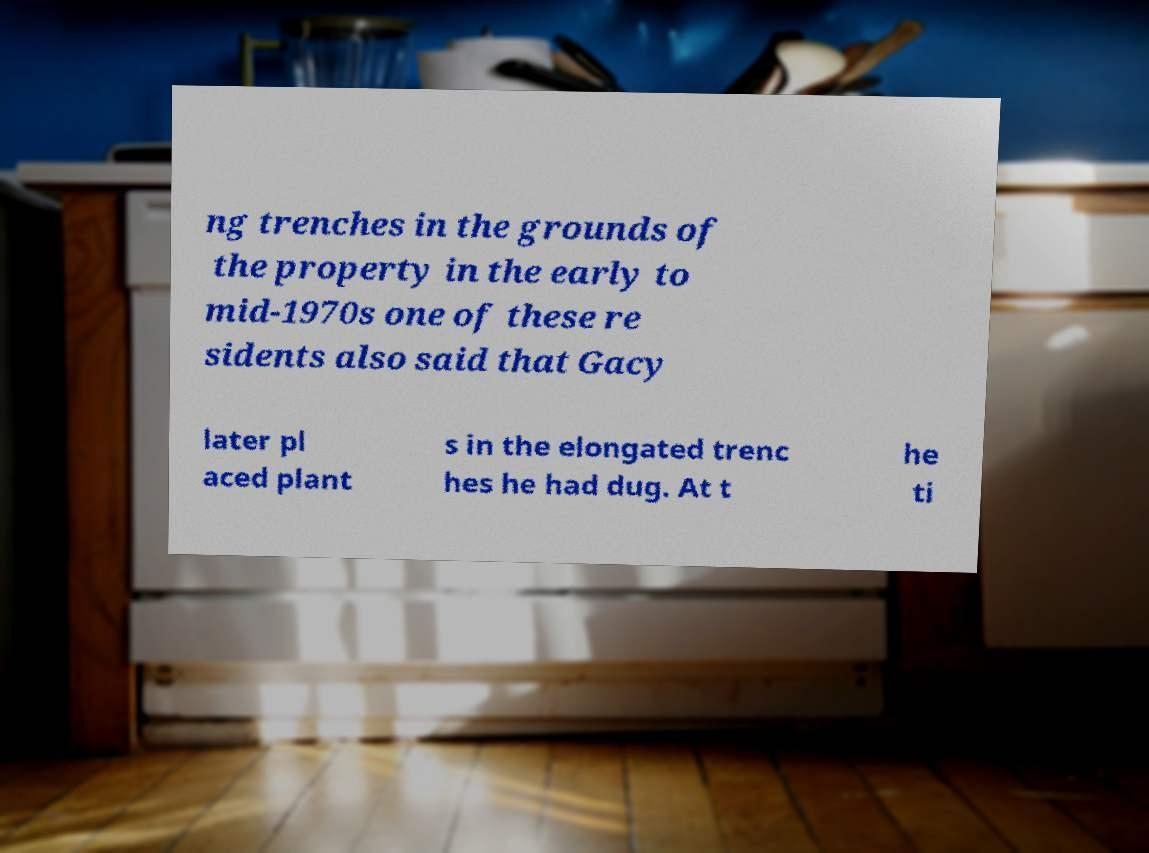Could you assist in decoding the text presented in this image and type it out clearly? ng trenches in the grounds of the property in the early to mid-1970s one of these re sidents also said that Gacy later pl aced plant s in the elongated trenc hes he had dug. At t he ti 